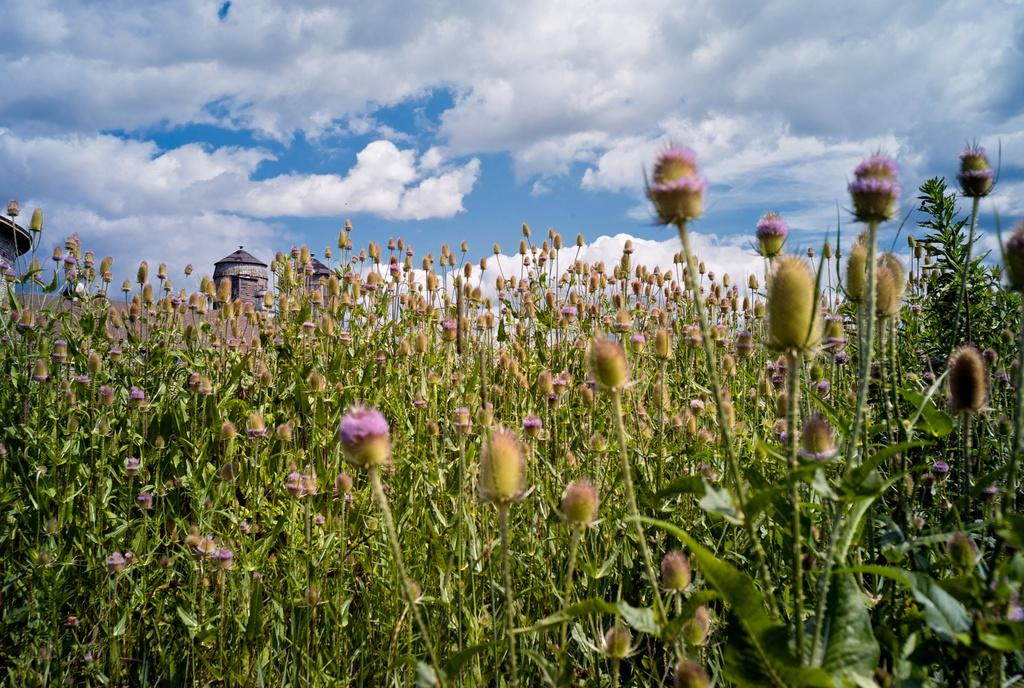What type of living organisms can be seen in the image? Plants and flowers are visible in the image. What can be seen in the background of the image? There are towers in the background of the image. What is visible at the top of the image? The sky is visible at the top of the image. What can be observed in the sky? There are clouds in the sky. What type of experience can be seen on the mouth of the plant in the image? There is no mouth present on the plants in the image, as plants do not have mouths. 